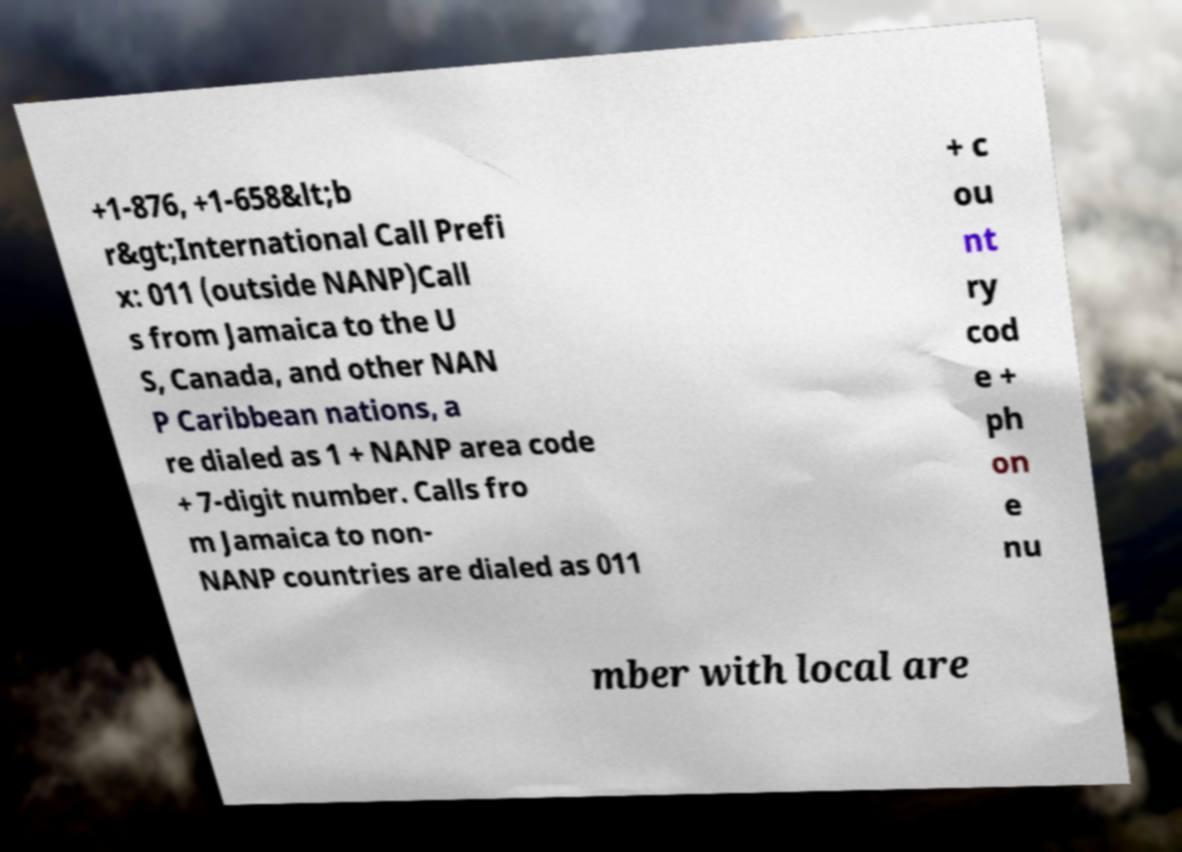Could you assist in decoding the text presented in this image and type it out clearly? +1-876, +1-658&lt;b r&gt;International Call Prefi x: 011 (outside NANP)Call s from Jamaica to the U S, Canada, and other NAN P Caribbean nations, a re dialed as 1 + NANP area code + 7-digit number. Calls fro m Jamaica to non- NANP countries are dialed as 011 + c ou nt ry cod e + ph on e nu mber with local are 